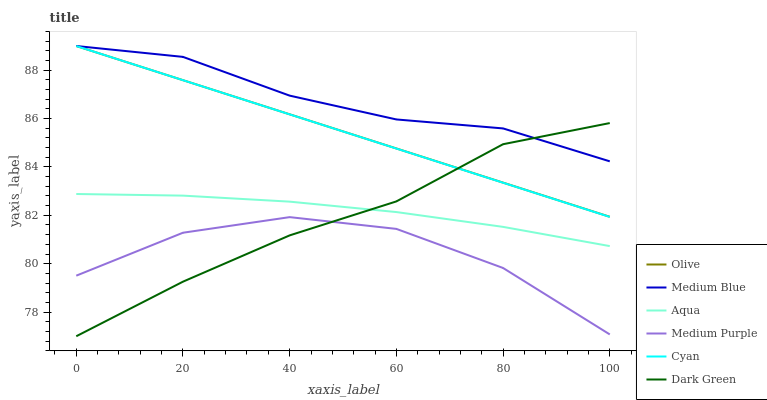Does Medium Purple have the minimum area under the curve?
Answer yes or no. Yes. Does Medium Blue have the maximum area under the curve?
Answer yes or no. Yes. Does Aqua have the minimum area under the curve?
Answer yes or no. No. Does Aqua have the maximum area under the curve?
Answer yes or no. No. Is Olive the smoothest?
Answer yes or no. Yes. Is Medium Purple the roughest?
Answer yes or no. Yes. Is Aqua the smoothest?
Answer yes or no. No. Is Aqua the roughest?
Answer yes or no. No. Does Dark Green have the lowest value?
Answer yes or no. Yes. Does Aqua have the lowest value?
Answer yes or no. No. Does Cyan have the highest value?
Answer yes or no. Yes. Does Aqua have the highest value?
Answer yes or no. No. Is Medium Purple less than Cyan?
Answer yes or no. Yes. Is Olive greater than Medium Purple?
Answer yes or no. Yes. Does Medium Blue intersect Cyan?
Answer yes or no. Yes. Is Medium Blue less than Cyan?
Answer yes or no. No. Is Medium Blue greater than Cyan?
Answer yes or no. No. Does Medium Purple intersect Cyan?
Answer yes or no. No. 